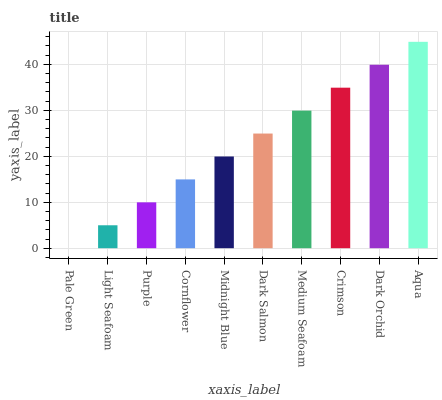Is Pale Green the minimum?
Answer yes or no. Yes. Is Aqua the maximum?
Answer yes or no. Yes. Is Light Seafoam the minimum?
Answer yes or no. No. Is Light Seafoam the maximum?
Answer yes or no. No. Is Light Seafoam greater than Pale Green?
Answer yes or no. Yes. Is Pale Green less than Light Seafoam?
Answer yes or no. Yes. Is Pale Green greater than Light Seafoam?
Answer yes or no. No. Is Light Seafoam less than Pale Green?
Answer yes or no. No. Is Dark Salmon the high median?
Answer yes or no. Yes. Is Midnight Blue the low median?
Answer yes or no. Yes. Is Aqua the high median?
Answer yes or no. No. Is Cornflower the low median?
Answer yes or no. No. 